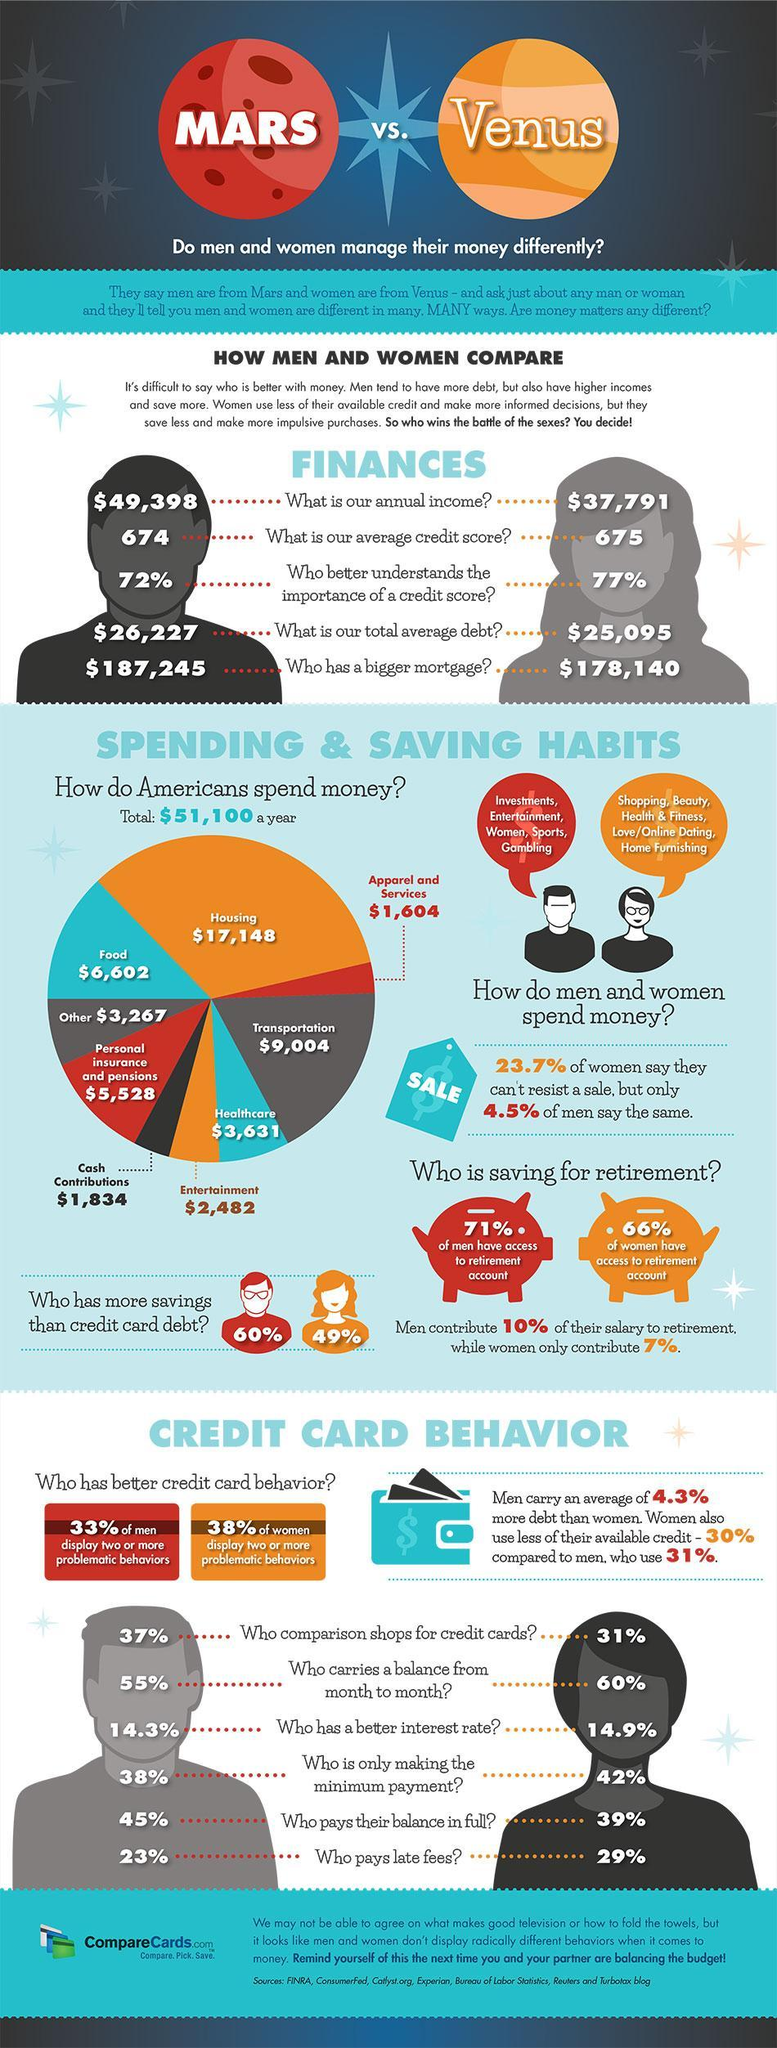What percentage of American women has savings than credit card debts?
Answer the question with a short phrase. 49% What percentage of American women make only minimum credit card payments? 42% What is the total average debt of women in America? $ 25,095 What percentage of American men pays their full credit card balance? 45% How much money is spend by the Americans on healthcare per year? $3,631 On which sector, Americans spend most of their money? Housing What percent of American men understands better about the importance of a credit score? 72% What is the average credit score of men in America? 674 